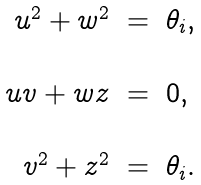<formula> <loc_0><loc_0><loc_500><loc_500>\begin{array} { r c l } u ^ { 2 } + w ^ { 2 } & = & \theta _ { i } , \\ \ & \ & \ \\ u v + w z & = & 0 , \\ \ & \ & \ \\ v ^ { 2 } + z ^ { 2 } & = & \theta _ { i } . \end{array}</formula> 